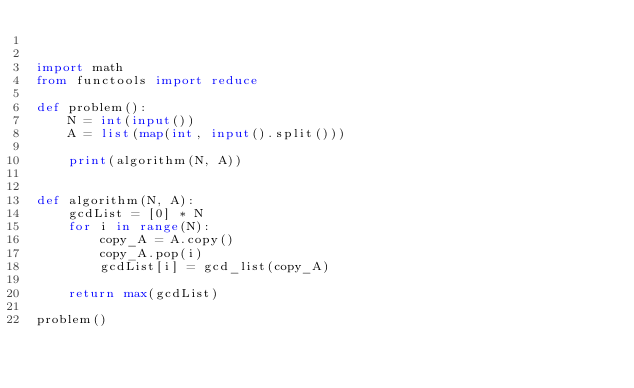Convert code to text. <code><loc_0><loc_0><loc_500><loc_500><_Python_>

import math
from functools import reduce

def problem():
    N = int(input())
    A = list(map(int, input().split()))

    print(algorithm(N, A))


def algorithm(N, A):
    gcdList = [0] * N
    for i in range(N):
        copy_A = A.copy()
        copy_A.pop(i)
        gcdList[i] = gcd_list(copy_A)

    return max(gcdList)

problem()</code> 